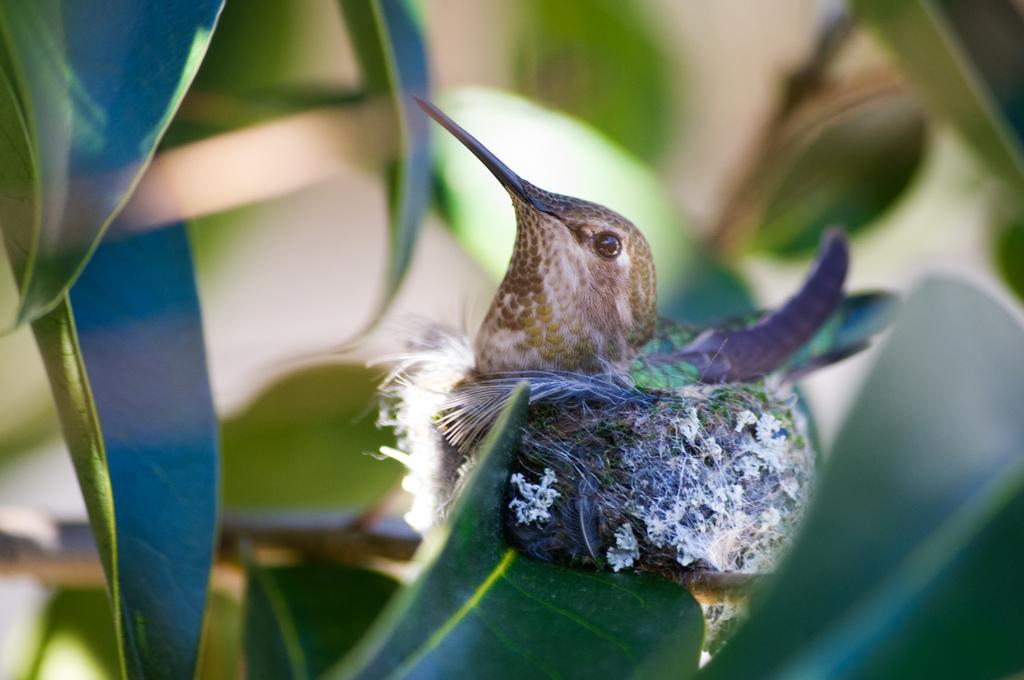How would you summarize this image in a sentence or two? In this image I can see the bird. The bird is in brown and violet color. It is on the leaf of the plant. And there is a blurred background. 